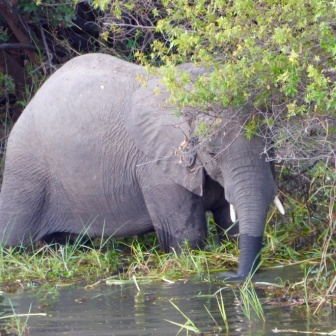Imagine you are a wildlife documentary narrator. Describe a dramatic moment based on this scene. Narrator: 'In the still heart of the African wilderness, a lone elephant embarks on a perilous quest for survival. As it edges towards the shimmering water, each step fraught with tension, it breaks through the dense thicket. This oasis, a lifeline amidst the arid landscape, offers both sustenance and risk. Unbeknownst to the elephant, predators could lie in wait, ready to pounce. But driven by an insatiable thirst and the need to sustain itself, our majestic giant braves the potential danger. Amidst the lush greenery and teeming life, the elephant's journey epitomizes the raw, unyielding spirit of the wild.' 